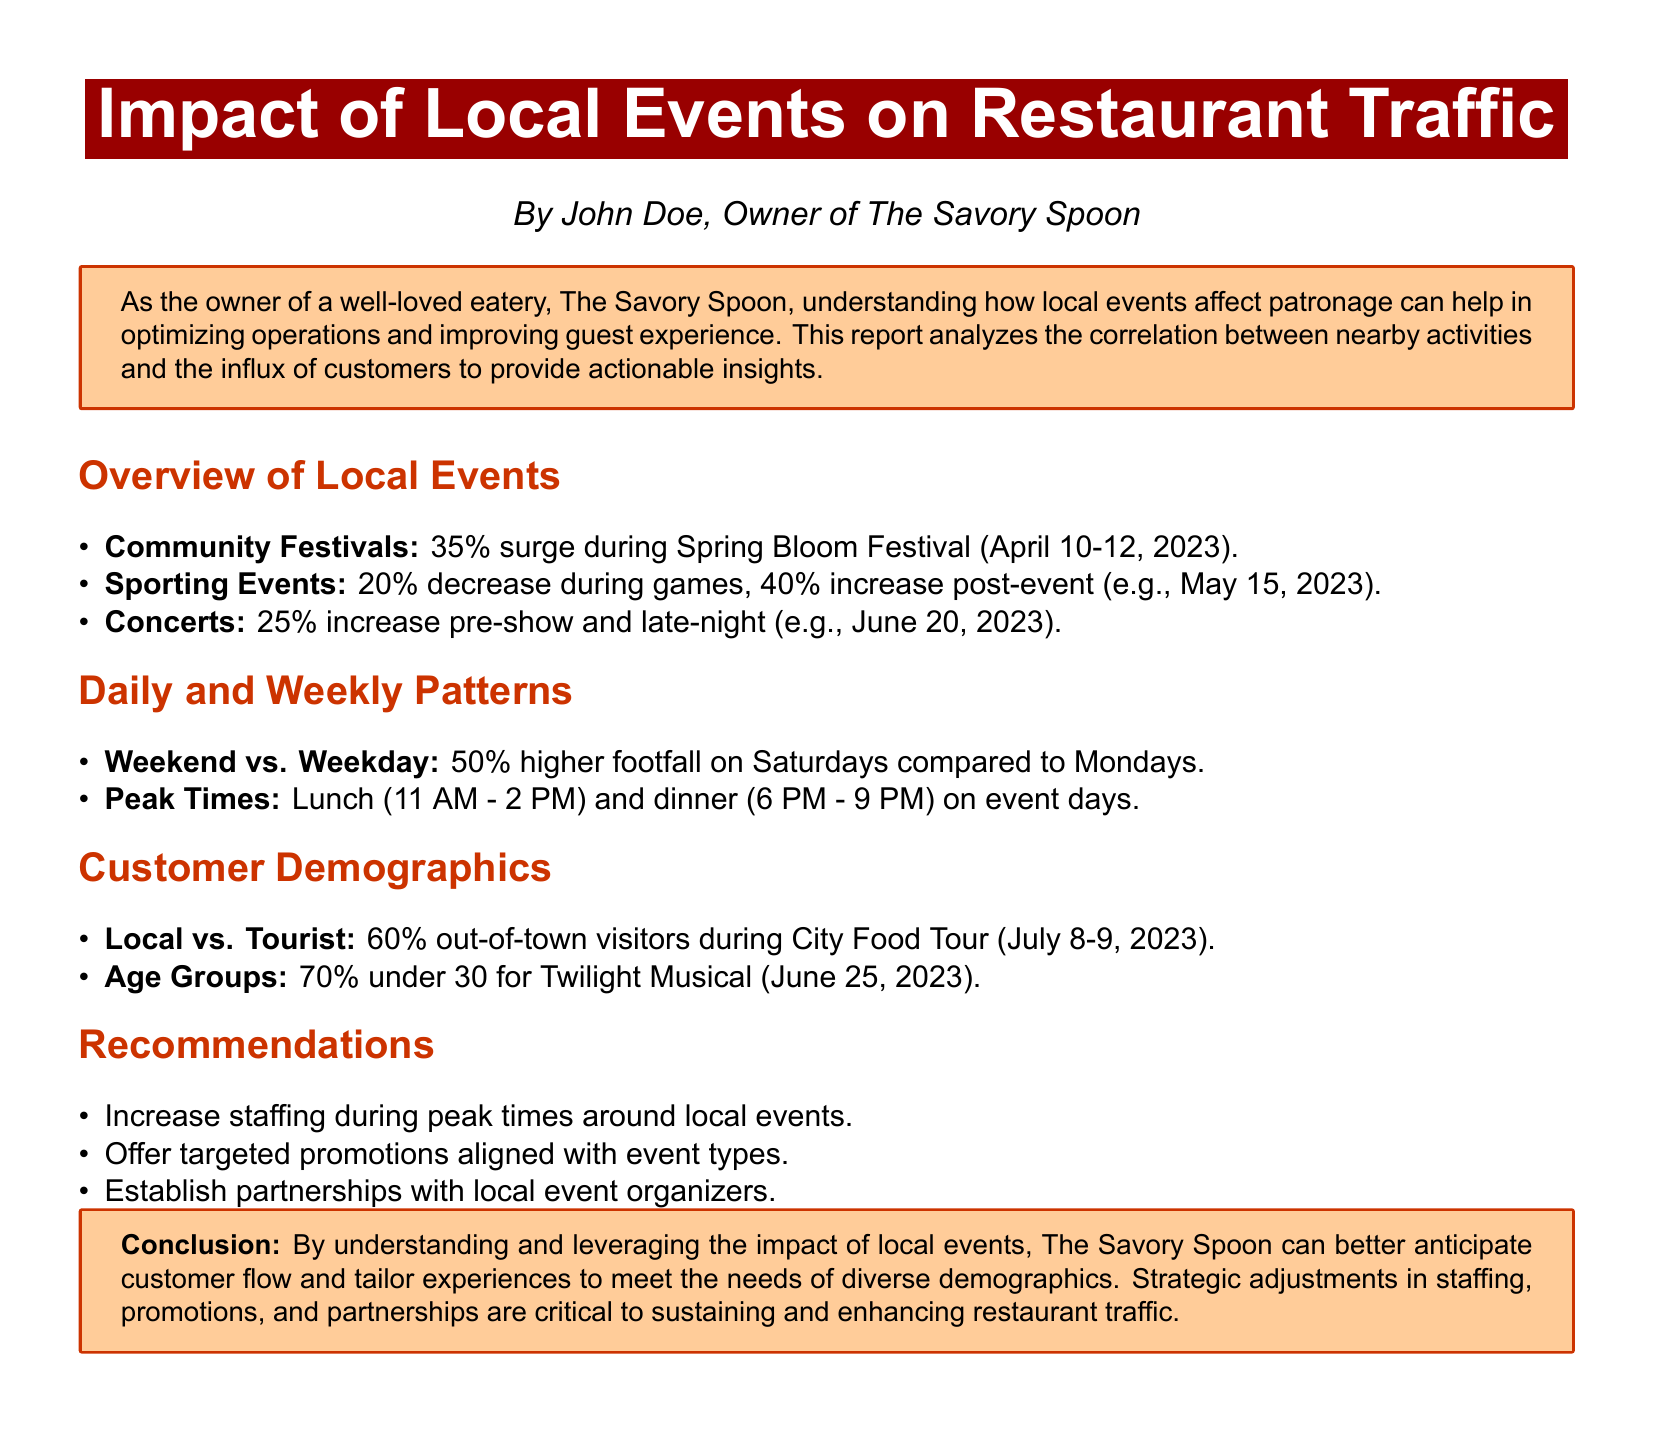What percentage increase in footfall is observed during the Spring Bloom Festival? The document states that there is a 35% surge during the Spring Bloom Festival.
Answer: 35% What is the peak time for customer influx on event days? The document mentions that peak times are lunch (11 AM - 2 PM) and dinner (6 PM - 9 PM).
Answer: 11 AM - 2 PM and 6 PM - 9 PM What demographic makes up 60% of visitors during the City Food Tour? The document indicates that 60% out-of-town visitors are present during the City Food Tour.
Answer: Out-of-town visitors What is the percentage decrease in traffic during sporting events? The document specifies there is a 20% decrease in traffic during games.
Answer: 20% Which age group accounts for 70% of attendees at the Twilight Musical? The document states that 70% under 30 are present for the Twilight Musical.
Answer: Under 30 What recommendation is suggested for staffing around local events? The document recommends increasing staffing during peak times around local events.
Answer: Increase staffing What happens to restaurant traffic after sporting events? The document notes a 40% increase in restaurant traffic post-event.
Answer: 40% increase What kind of partnerships does the report suggest establishing? The document suggests establishing partnerships with local event organizers.
Answer: Local event organizers What is the footfall comparison between weekends and weekdays? The report indicates that footfall is 50% higher on Saturdays compared to Mondays.
Answer: 50% higher 